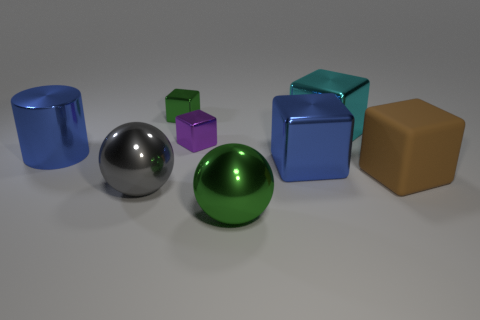Subtract all large cubes. How many cubes are left? 2 Subtract 2 balls. How many balls are left? 0 Add 1 balls. How many objects exist? 9 Subtract all spheres. How many objects are left? 6 Subtract all green blocks. How many blocks are left? 4 Subtract all blue spheres. Subtract all green cylinders. How many spheres are left? 2 Subtract all brown cylinders. How many brown spheres are left? 0 Add 7 big metallic balls. How many big metallic balls exist? 9 Subtract 0 gray cylinders. How many objects are left? 8 Subtract all blue shiny blocks. Subtract all small green metal cubes. How many objects are left? 6 